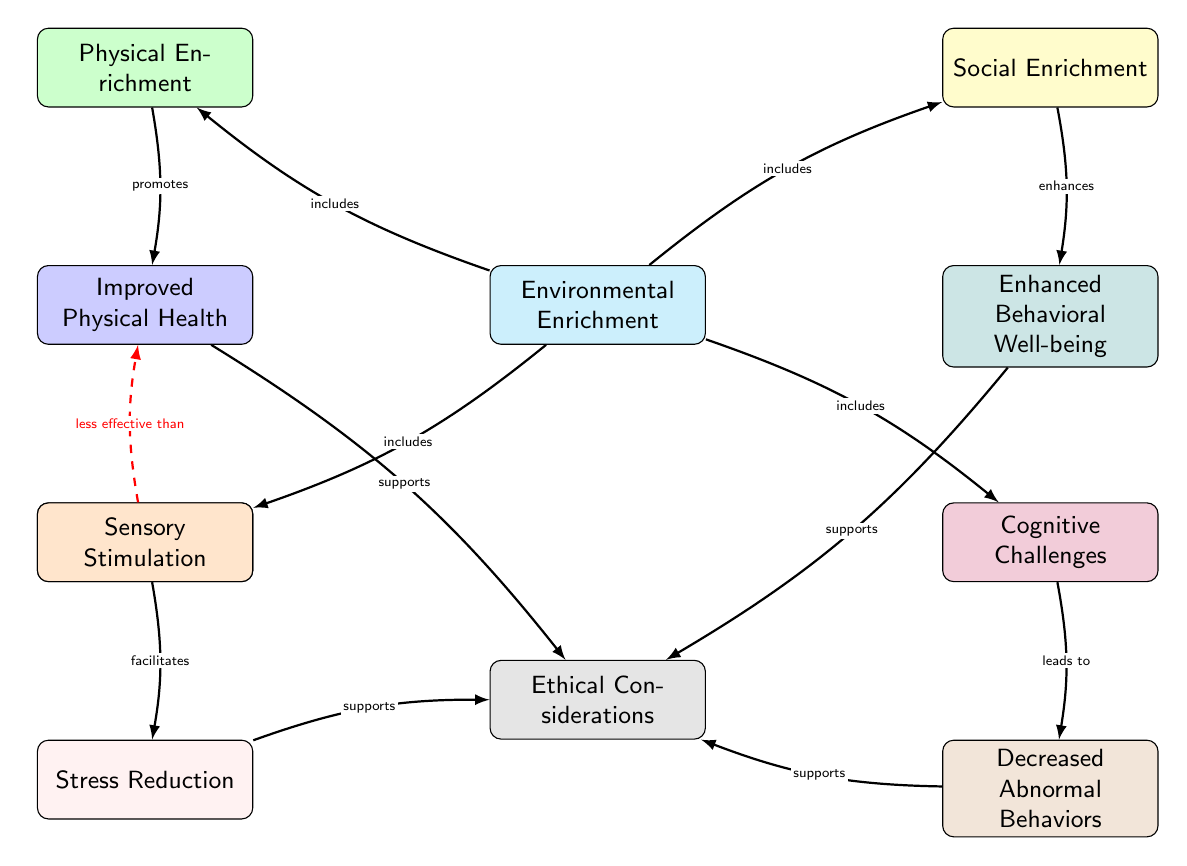What are the components of environmental enrichment represented in the diagram? The diagram shows four components of environmental enrichment: Physical Enrichment, Social Enrichment, Sensory Stimulation, and Cognitive Challenges.
Answer: Physical Enrichment, Social Enrichment, Sensory Stimulation, Cognitive Challenges Which node indicates the outcome for improved physical health? The node representing the outcome for improved physical health is positioned below Physical Enrichment and is directly connected to it.
Answer: Improved Physical Health How many edges are leading to the Ethical Considerations node? The Ethical Considerations node has four incoming edges, one from each of the four outcome nodes.
Answer: 4 Which type of enrichment facilitates stress reduction according to the diagram? The diagram clearly shows that Sensory Stimulation is the type of enrichment that facilitates stress reduction, as indicated by its direct connection to the Stress Reduction node.
Answer: Sensory Stimulation What is less effective than improved physical health in the diagram? The diagram states that Standard Lab Conditions are less effective than Improved Physical Health, evidenced by the dashed red edge connecting them.
Answer: Standard Lab Conditions What relationships do the Social Enrichment and Enhanced Behavioral Well-being share in the diagram? The diagram shows that Social Enrichment enhances Behavioral Well-being. This relationship is signified by the directed edge connecting the two nodes.
Answer: enhances Which type of enrichment leads to decreased abnormal behaviors? Cognitive Challenges lead to decreased abnormal behaviors as indicated in the diagram, where there is a direct connection to that outcome.
Answer: Cognitive Challenges How many types of enrichment include Social Enrichment as per the diagram? Social Enrichment is included in the Environmental Enrichment node, shown by the directed edge that connects them. Thus, there is one type (Social Enrichment).
Answer: 1 What supports the Ethical Considerations according to the diagram? The diagram shows that all four outcomes, Improved Physical Health, Enhanced Behavioral Well-being, Stress Reduction, and Decreased Abnormal Behaviors, support Ethical Considerations.
Answer: 4 